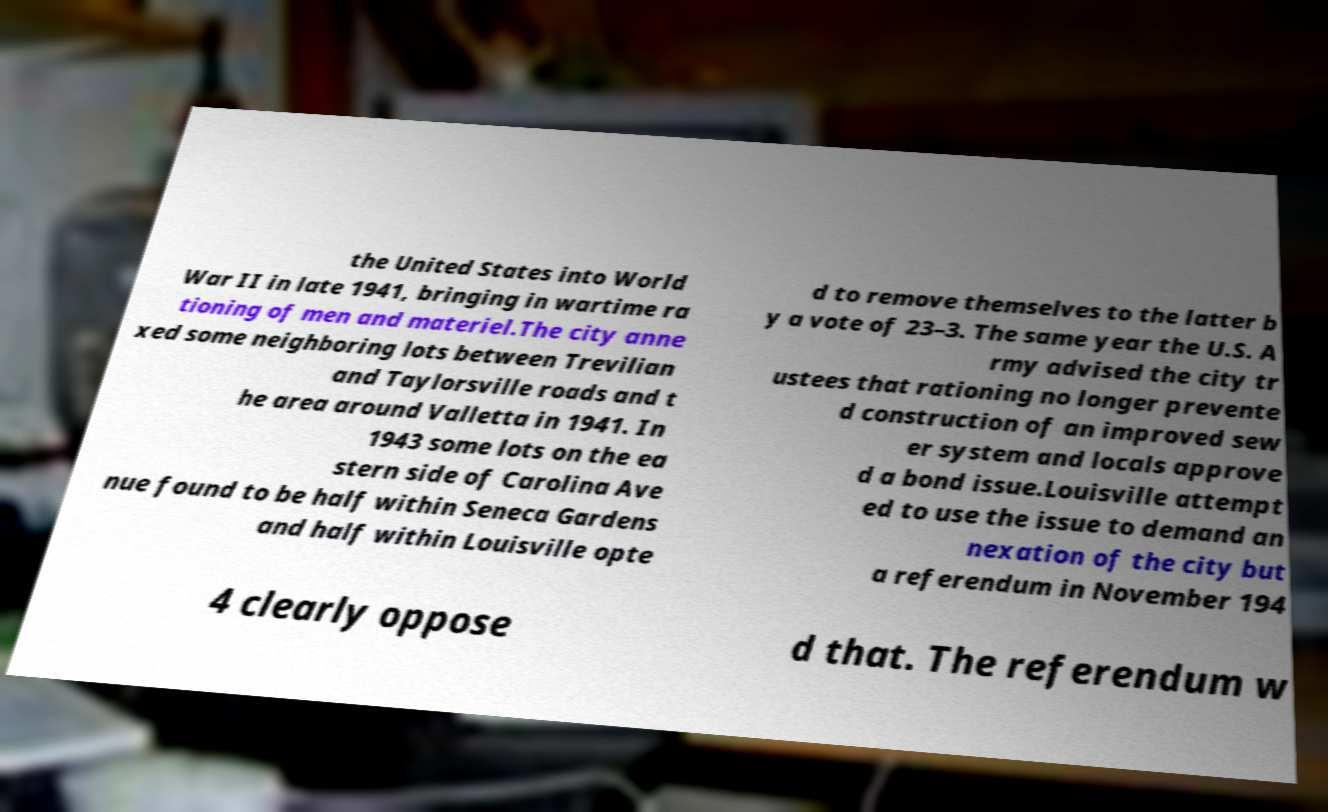Could you assist in decoding the text presented in this image and type it out clearly? the United States into World War II in late 1941, bringing in wartime ra tioning of men and materiel.The city anne xed some neighboring lots between Trevilian and Taylorsville roads and t he area around Valletta in 1941. In 1943 some lots on the ea stern side of Carolina Ave nue found to be half within Seneca Gardens and half within Louisville opte d to remove themselves to the latter b y a vote of 23–3. The same year the U.S. A rmy advised the city tr ustees that rationing no longer prevente d construction of an improved sew er system and locals approve d a bond issue.Louisville attempt ed to use the issue to demand an nexation of the city but a referendum in November 194 4 clearly oppose d that. The referendum w 